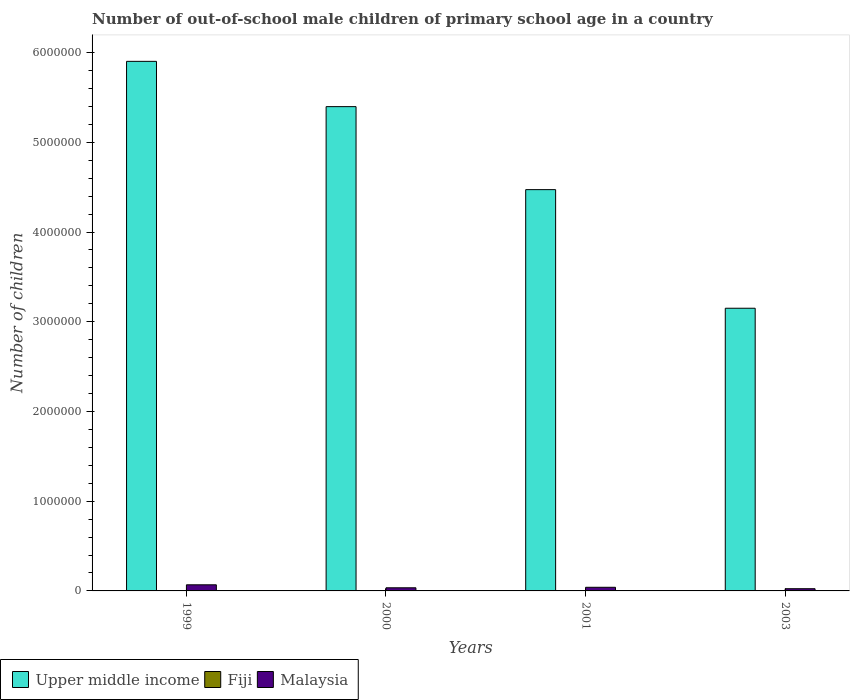How many groups of bars are there?
Offer a very short reply. 4. Are the number of bars on each tick of the X-axis equal?
Your response must be concise. Yes. How many bars are there on the 1st tick from the right?
Provide a succinct answer. 3. In how many cases, is the number of bars for a given year not equal to the number of legend labels?
Offer a very short reply. 0. What is the number of out-of-school male children in Upper middle income in 1999?
Your answer should be very brief. 5.90e+06. Across all years, what is the maximum number of out-of-school male children in Malaysia?
Ensure brevity in your answer.  6.82e+04. Across all years, what is the minimum number of out-of-school male children in Malaysia?
Your answer should be compact. 2.46e+04. In which year was the number of out-of-school male children in Upper middle income maximum?
Make the answer very short. 1999. In which year was the number of out-of-school male children in Fiji minimum?
Your response must be concise. 2003. What is the total number of out-of-school male children in Malaysia in the graph?
Your answer should be compact. 1.68e+05. What is the difference between the number of out-of-school male children in Upper middle income in 2000 and that in 2001?
Offer a very short reply. 9.25e+05. What is the difference between the number of out-of-school male children in Upper middle income in 2003 and the number of out-of-school male children in Fiji in 1999?
Your response must be concise. 3.15e+06. What is the average number of out-of-school male children in Fiji per year?
Make the answer very short. 2235.5. In the year 2003, what is the difference between the number of out-of-school male children in Malaysia and number of out-of-school male children in Upper middle income?
Ensure brevity in your answer.  -3.13e+06. In how many years, is the number of out-of-school male children in Malaysia greater than 1600000?
Make the answer very short. 0. What is the ratio of the number of out-of-school male children in Upper middle income in 2000 to that in 2001?
Offer a very short reply. 1.21. Is the difference between the number of out-of-school male children in Malaysia in 1999 and 2001 greater than the difference between the number of out-of-school male children in Upper middle income in 1999 and 2001?
Keep it short and to the point. No. What is the difference between the highest and the second highest number of out-of-school male children in Upper middle income?
Keep it short and to the point. 5.05e+05. What is the difference between the highest and the lowest number of out-of-school male children in Upper middle income?
Provide a short and direct response. 2.75e+06. In how many years, is the number of out-of-school male children in Fiji greater than the average number of out-of-school male children in Fiji taken over all years?
Offer a terse response. 2. Is the sum of the number of out-of-school male children in Upper middle income in 2000 and 2001 greater than the maximum number of out-of-school male children in Fiji across all years?
Offer a terse response. Yes. What does the 1st bar from the left in 2001 represents?
Offer a very short reply. Upper middle income. What does the 1st bar from the right in 1999 represents?
Keep it short and to the point. Malaysia. How many bars are there?
Provide a short and direct response. 12. How many years are there in the graph?
Provide a succinct answer. 4. Are the values on the major ticks of Y-axis written in scientific E-notation?
Ensure brevity in your answer.  No. Does the graph contain any zero values?
Your answer should be compact. No. How many legend labels are there?
Your response must be concise. 3. How are the legend labels stacked?
Provide a succinct answer. Horizontal. What is the title of the graph?
Give a very brief answer. Number of out-of-school male children of primary school age in a country. Does "United Kingdom" appear as one of the legend labels in the graph?
Provide a succinct answer. No. What is the label or title of the X-axis?
Provide a succinct answer. Years. What is the label or title of the Y-axis?
Your response must be concise. Number of children. What is the Number of children in Upper middle income in 1999?
Provide a succinct answer. 5.90e+06. What is the Number of children in Fiji in 1999?
Provide a short and direct response. 3458. What is the Number of children of Malaysia in 1999?
Ensure brevity in your answer.  6.82e+04. What is the Number of children of Upper middle income in 2000?
Give a very brief answer. 5.40e+06. What is the Number of children of Fiji in 2000?
Your answer should be very brief. 3094. What is the Number of children of Malaysia in 2000?
Offer a terse response. 3.48e+04. What is the Number of children of Upper middle income in 2001?
Give a very brief answer. 4.47e+06. What is the Number of children in Fiji in 2001?
Offer a terse response. 1433. What is the Number of children of Malaysia in 2001?
Your response must be concise. 4.04e+04. What is the Number of children of Upper middle income in 2003?
Your answer should be compact. 3.15e+06. What is the Number of children of Fiji in 2003?
Keep it short and to the point. 957. What is the Number of children in Malaysia in 2003?
Provide a short and direct response. 2.46e+04. Across all years, what is the maximum Number of children of Upper middle income?
Offer a terse response. 5.90e+06. Across all years, what is the maximum Number of children of Fiji?
Your answer should be compact. 3458. Across all years, what is the maximum Number of children of Malaysia?
Offer a terse response. 6.82e+04. Across all years, what is the minimum Number of children in Upper middle income?
Your response must be concise. 3.15e+06. Across all years, what is the minimum Number of children in Fiji?
Ensure brevity in your answer.  957. Across all years, what is the minimum Number of children in Malaysia?
Your response must be concise. 2.46e+04. What is the total Number of children of Upper middle income in the graph?
Your answer should be compact. 1.89e+07. What is the total Number of children of Fiji in the graph?
Ensure brevity in your answer.  8942. What is the total Number of children of Malaysia in the graph?
Your answer should be very brief. 1.68e+05. What is the difference between the Number of children in Upper middle income in 1999 and that in 2000?
Keep it short and to the point. 5.05e+05. What is the difference between the Number of children of Fiji in 1999 and that in 2000?
Your answer should be compact. 364. What is the difference between the Number of children of Malaysia in 1999 and that in 2000?
Your answer should be compact. 3.33e+04. What is the difference between the Number of children of Upper middle income in 1999 and that in 2001?
Give a very brief answer. 1.43e+06. What is the difference between the Number of children in Fiji in 1999 and that in 2001?
Offer a terse response. 2025. What is the difference between the Number of children of Malaysia in 1999 and that in 2001?
Make the answer very short. 2.77e+04. What is the difference between the Number of children of Upper middle income in 1999 and that in 2003?
Offer a terse response. 2.75e+06. What is the difference between the Number of children of Fiji in 1999 and that in 2003?
Keep it short and to the point. 2501. What is the difference between the Number of children of Malaysia in 1999 and that in 2003?
Your answer should be compact. 4.36e+04. What is the difference between the Number of children of Upper middle income in 2000 and that in 2001?
Your answer should be very brief. 9.25e+05. What is the difference between the Number of children of Fiji in 2000 and that in 2001?
Offer a terse response. 1661. What is the difference between the Number of children of Malaysia in 2000 and that in 2001?
Provide a short and direct response. -5563. What is the difference between the Number of children in Upper middle income in 2000 and that in 2003?
Your response must be concise. 2.25e+06. What is the difference between the Number of children in Fiji in 2000 and that in 2003?
Ensure brevity in your answer.  2137. What is the difference between the Number of children in Malaysia in 2000 and that in 2003?
Offer a terse response. 1.02e+04. What is the difference between the Number of children of Upper middle income in 2001 and that in 2003?
Provide a succinct answer. 1.32e+06. What is the difference between the Number of children of Fiji in 2001 and that in 2003?
Offer a very short reply. 476. What is the difference between the Number of children of Malaysia in 2001 and that in 2003?
Provide a short and direct response. 1.58e+04. What is the difference between the Number of children of Upper middle income in 1999 and the Number of children of Fiji in 2000?
Your answer should be very brief. 5.90e+06. What is the difference between the Number of children of Upper middle income in 1999 and the Number of children of Malaysia in 2000?
Make the answer very short. 5.87e+06. What is the difference between the Number of children in Fiji in 1999 and the Number of children in Malaysia in 2000?
Keep it short and to the point. -3.14e+04. What is the difference between the Number of children in Upper middle income in 1999 and the Number of children in Fiji in 2001?
Ensure brevity in your answer.  5.90e+06. What is the difference between the Number of children in Upper middle income in 1999 and the Number of children in Malaysia in 2001?
Offer a very short reply. 5.86e+06. What is the difference between the Number of children of Fiji in 1999 and the Number of children of Malaysia in 2001?
Make the answer very short. -3.69e+04. What is the difference between the Number of children in Upper middle income in 1999 and the Number of children in Fiji in 2003?
Make the answer very short. 5.90e+06. What is the difference between the Number of children in Upper middle income in 1999 and the Number of children in Malaysia in 2003?
Your answer should be compact. 5.88e+06. What is the difference between the Number of children in Fiji in 1999 and the Number of children in Malaysia in 2003?
Make the answer very short. -2.11e+04. What is the difference between the Number of children of Upper middle income in 2000 and the Number of children of Fiji in 2001?
Provide a short and direct response. 5.40e+06. What is the difference between the Number of children in Upper middle income in 2000 and the Number of children in Malaysia in 2001?
Ensure brevity in your answer.  5.36e+06. What is the difference between the Number of children of Fiji in 2000 and the Number of children of Malaysia in 2001?
Your response must be concise. -3.73e+04. What is the difference between the Number of children in Upper middle income in 2000 and the Number of children in Fiji in 2003?
Your answer should be very brief. 5.40e+06. What is the difference between the Number of children of Upper middle income in 2000 and the Number of children of Malaysia in 2003?
Ensure brevity in your answer.  5.37e+06. What is the difference between the Number of children of Fiji in 2000 and the Number of children of Malaysia in 2003?
Provide a succinct answer. -2.15e+04. What is the difference between the Number of children of Upper middle income in 2001 and the Number of children of Fiji in 2003?
Your answer should be compact. 4.47e+06. What is the difference between the Number of children of Upper middle income in 2001 and the Number of children of Malaysia in 2003?
Offer a terse response. 4.45e+06. What is the difference between the Number of children of Fiji in 2001 and the Number of children of Malaysia in 2003?
Your answer should be compact. -2.32e+04. What is the average Number of children of Upper middle income per year?
Make the answer very short. 4.73e+06. What is the average Number of children of Fiji per year?
Keep it short and to the point. 2235.5. What is the average Number of children of Malaysia per year?
Ensure brevity in your answer.  4.20e+04. In the year 1999, what is the difference between the Number of children in Upper middle income and Number of children in Fiji?
Offer a very short reply. 5.90e+06. In the year 1999, what is the difference between the Number of children in Upper middle income and Number of children in Malaysia?
Your answer should be compact. 5.83e+06. In the year 1999, what is the difference between the Number of children in Fiji and Number of children in Malaysia?
Your answer should be compact. -6.47e+04. In the year 2000, what is the difference between the Number of children of Upper middle income and Number of children of Fiji?
Keep it short and to the point. 5.39e+06. In the year 2000, what is the difference between the Number of children of Upper middle income and Number of children of Malaysia?
Make the answer very short. 5.36e+06. In the year 2000, what is the difference between the Number of children of Fiji and Number of children of Malaysia?
Offer a very short reply. -3.18e+04. In the year 2001, what is the difference between the Number of children in Upper middle income and Number of children in Fiji?
Give a very brief answer. 4.47e+06. In the year 2001, what is the difference between the Number of children of Upper middle income and Number of children of Malaysia?
Give a very brief answer. 4.43e+06. In the year 2001, what is the difference between the Number of children of Fiji and Number of children of Malaysia?
Your answer should be compact. -3.90e+04. In the year 2003, what is the difference between the Number of children of Upper middle income and Number of children of Fiji?
Provide a short and direct response. 3.15e+06. In the year 2003, what is the difference between the Number of children of Upper middle income and Number of children of Malaysia?
Give a very brief answer. 3.13e+06. In the year 2003, what is the difference between the Number of children of Fiji and Number of children of Malaysia?
Your answer should be very brief. -2.36e+04. What is the ratio of the Number of children in Upper middle income in 1999 to that in 2000?
Give a very brief answer. 1.09. What is the ratio of the Number of children in Fiji in 1999 to that in 2000?
Keep it short and to the point. 1.12. What is the ratio of the Number of children of Malaysia in 1999 to that in 2000?
Give a very brief answer. 1.96. What is the ratio of the Number of children in Upper middle income in 1999 to that in 2001?
Make the answer very short. 1.32. What is the ratio of the Number of children of Fiji in 1999 to that in 2001?
Make the answer very short. 2.41. What is the ratio of the Number of children of Malaysia in 1999 to that in 2001?
Give a very brief answer. 1.69. What is the ratio of the Number of children in Upper middle income in 1999 to that in 2003?
Offer a very short reply. 1.87. What is the ratio of the Number of children of Fiji in 1999 to that in 2003?
Make the answer very short. 3.61. What is the ratio of the Number of children in Malaysia in 1999 to that in 2003?
Ensure brevity in your answer.  2.77. What is the ratio of the Number of children of Upper middle income in 2000 to that in 2001?
Make the answer very short. 1.21. What is the ratio of the Number of children in Fiji in 2000 to that in 2001?
Provide a succinct answer. 2.16. What is the ratio of the Number of children of Malaysia in 2000 to that in 2001?
Offer a terse response. 0.86. What is the ratio of the Number of children in Upper middle income in 2000 to that in 2003?
Offer a very short reply. 1.71. What is the ratio of the Number of children of Fiji in 2000 to that in 2003?
Offer a very short reply. 3.23. What is the ratio of the Number of children of Malaysia in 2000 to that in 2003?
Your answer should be compact. 1.42. What is the ratio of the Number of children of Upper middle income in 2001 to that in 2003?
Offer a terse response. 1.42. What is the ratio of the Number of children in Fiji in 2001 to that in 2003?
Provide a succinct answer. 1.5. What is the ratio of the Number of children in Malaysia in 2001 to that in 2003?
Provide a succinct answer. 1.64. What is the difference between the highest and the second highest Number of children of Upper middle income?
Your response must be concise. 5.05e+05. What is the difference between the highest and the second highest Number of children of Fiji?
Make the answer very short. 364. What is the difference between the highest and the second highest Number of children in Malaysia?
Your answer should be compact. 2.77e+04. What is the difference between the highest and the lowest Number of children in Upper middle income?
Keep it short and to the point. 2.75e+06. What is the difference between the highest and the lowest Number of children in Fiji?
Give a very brief answer. 2501. What is the difference between the highest and the lowest Number of children of Malaysia?
Give a very brief answer. 4.36e+04. 